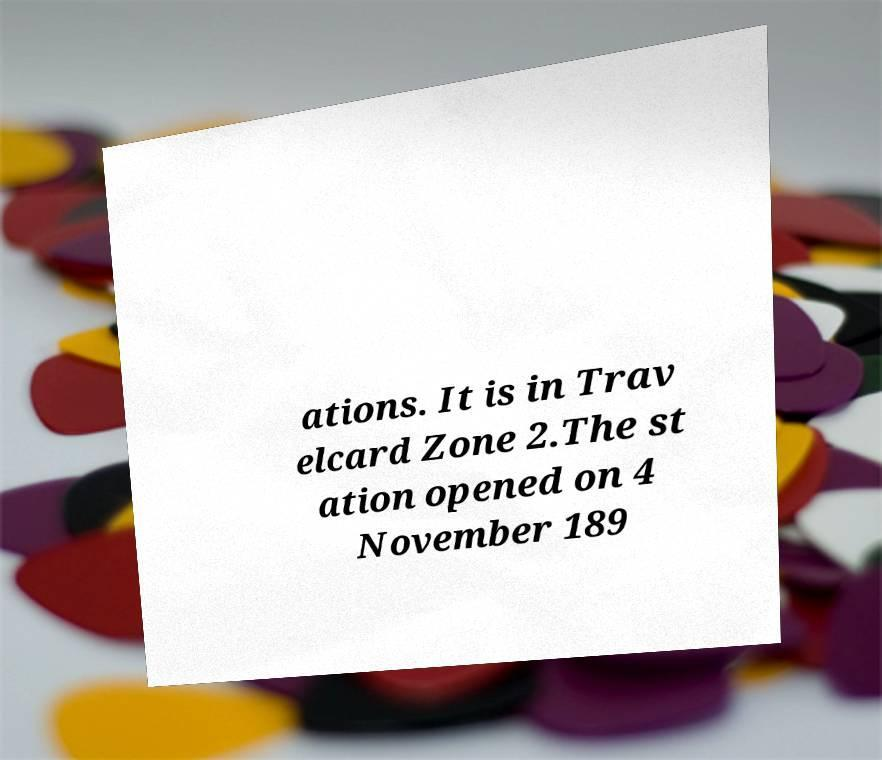Please read and relay the text visible in this image. What does it say? ations. It is in Trav elcard Zone 2.The st ation opened on 4 November 189 